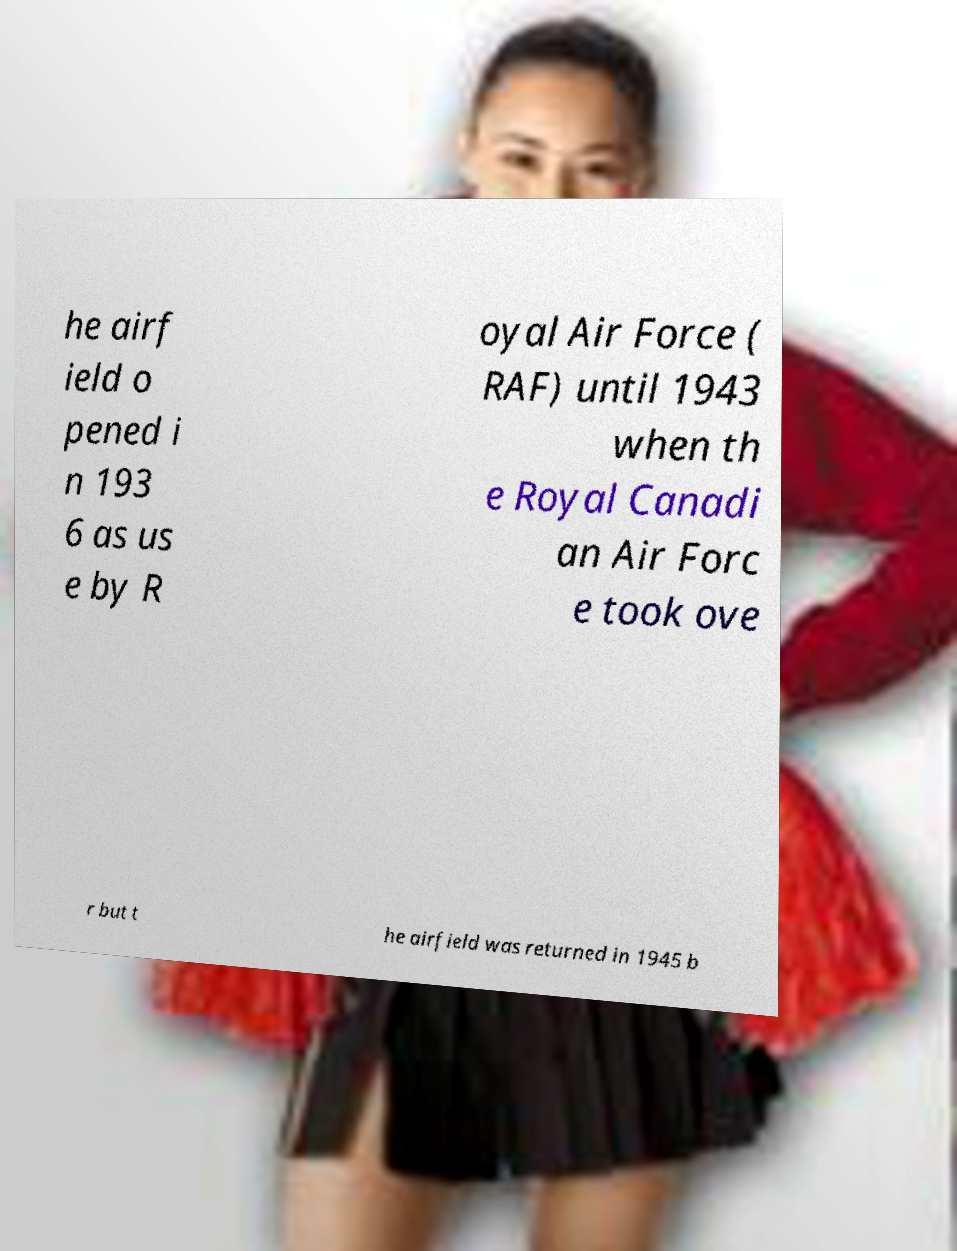Could you extract and type out the text from this image? he airf ield o pened i n 193 6 as us e by R oyal Air Force ( RAF) until 1943 when th e Royal Canadi an Air Forc e took ove r but t he airfield was returned in 1945 b 